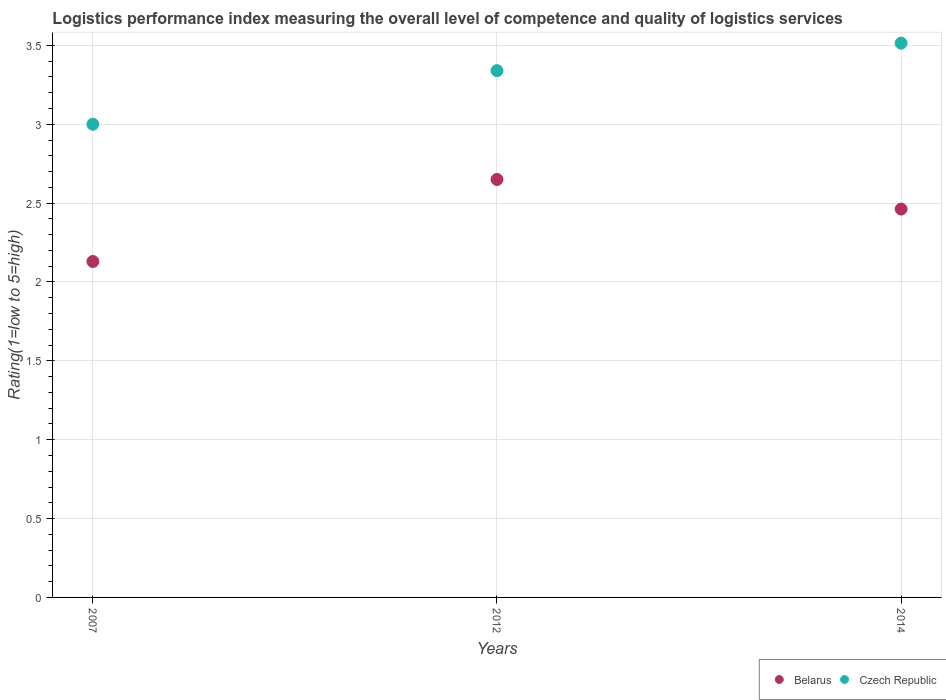What is the Logistic performance index in Belarus in 2007?
Your response must be concise. 2.13. Across all years, what is the maximum Logistic performance index in Czech Republic?
Ensure brevity in your answer.  3.51. In which year was the Logistic performance index in Belarus maximum?
Make the answer very short. 2012. In which year was the Logistic performance index in Czech Republic minimum?
Your answer should be very brief. 2007. What is the total Logistic performance index in Czech Republic in the graph?
Provide a succinct answer. 9.85. What is the difference between the Logistic performance index in Belarus in 2012 and that in 2014?
Your answer should be very brief. 0.19. What is the difference between the Logistic performance index in Czech Republic in 2014 and the Logistic performance index in Belarus in 2012?
Your answer should be compact. 0.86. What is the average Logistic performance index in Czech Republic per year?
Provide a short and direct response. 3.28. In the year 2007, what is the difference between the Logistic performance index in Czech Republic and Logistic performance index in Belarus?
Give a very brief answer. 0.87. In how many years, is the Logistic performance index in Belarus greater than 1?
Keep it short and to the point. 3. What is the ratio of the Logistic performance index in Belarus in 2012 to that in 2014?
Offer a terse response. 1.08. Is the Logistic performance index in Belarus in 2007 less than that in 2014?
Your response must be concise. Yes. Is the difference between the Logistic performance index in Czech Republic in 2007 and 2014 greater than the difference between the Logistic performance index in Belarus in 2007 and 2014?
Your response must be concise. No. What is the difference between the highest and the second highest Logistic performance index in Czech Republic?
Keep it short and to the point. 0.17. What is the difference between the highest and the lowest Logistic performance index in Belarus?
Your response must be concise. 0.52. In how many years, is the Logistic performance index in Czech Republic greater than the average Logistic performance index in Czech Republic taken over all years?
Make the answer very short. 2. Is the sum of the Logistic performance index in Czech Republic in 2012 and 2014 greater than the maximum Logistic performance index in Belarus across all years?
Ensure brevity in your answer.  Yes. Does the Logistic performance index in Belarus monotonically increase over the years?
Your answer should be compact. No. Is the Logistic performance index in Czech Republic strictly less than the Logistic performance index in Belarus over the years?
Offer a terse response. No. What is the difference between two consecutive major ticks on the Y-axis?
Make the answer very short. 0.5. Does the graph contain grids?
Give a very brief answer. Yes. Where does the legend appear in the graph?
Provide a succinct answer. Bottom right. How many legend labels are there?
Your response must be concise. 2. What is the title of the graph?
Your answer should be compact. Logistics performance index measuring the overall level of competence and quality of logistics services. Does "Sri Lanka" appear as one of the legend labels in the graph?
Offer a terse response. No. What is the label or title of the X-axis?
Provide a succinct answer. Years. What is the label or title of the Y-axis?
Keep it short and to the point. Rating(1=low to 5=high). What is the Rating(1=low to 5=high) of Belarus in 2007?
Your answer should be compact. 2.13. What is the Rating(1=low to 5=high) in Belarus in 2012?
Give a very brief answer. 2.65. What is the Rating(1=low to 5=high) of Czech Republic in 2012?
Keep it short and to the point. 3.34. What is the Rating(1=low to 5=high) of Belarus in 2014?
Keep it short and to the point. 2.46. What is the Rating(1=low to 5=high) in Czech Republic in 2014?
Ensure brevity in your answer.  3.51. Across all years, what is the maximum Rating(1=low to 5=high) in Belarus?
Provide a succinct answer. 2.65. Across all years, what is the maximum Rating(1=low to 5=high) in Czech Republic?
Offer a very short reply. 3.51. Across all years, what is the minimum Rating(1=low to 5=high) of Belarus?
Your answer should be very brief. 2.13. Across all years, what is the minimum Rating(1=low to 5=high) of Czech Republic?
Offer a very short reply. 3. What is the total Rating(1=low to 5=high) of Belarus in the graph?
Ensure brevity in your answer.  7.24. What is the total Rating(1=low to 5=high) in Czech Republic in the graph?
Make the answer very short. 9.85. What is the difference between the Rating(1=low to 5=high) of Belarus in 2007 and that in 2012?
Provide a succinct answer. -0.52. What is the difference between the Rating(1=low to 5=high) in Czech Republic in 2007 and that in 2012?
Provide a short and direct response. -0.34. What is the difference between the Rating(1=low to 5=high) in Belarus in 2007 and that in 2014?
Offer a terse response. -0.33. What is the difference between the Rating(1=low to 5=high) in Czech Republic in 2007 and that in 2014?
Give a very brief answer. -0.51. What is the difference between the Rating(1=low to 5=high) in Belarus in 2012 and that in 2014?
Offer a very short reply. 0.19. What is the difference between the Rating(1=low to 5=high) of Czech Republic in 2012 and that in 2014?
Your answer should be compact. -0.17. What is the difference between the Rating(1=low to 5=high) of Belarus in 2007 and the Rating(1=low to 5=high) of Czech Republic in 2012?
Ensure brevity in your answer.  -1.21. What is the difference between the Rating(1=low to 5=high) of Belarus in 2007 and the Rating(1=low to 5=high) of Czech Republic in 2014?
Your answer should be very brief. -1.38. What is the difference between the Rating(1=low to 5=high) in Belarus in 2012 and the Rating(1=low to 5=high) in Czech Republic in 2014?
Your answer should be compact. -0.86. What is the average Rating(1=low to 5=high) of Belarus per year?
Ensure brevity in your answer.  2.41. What is the average Rating(1=low to 5=high) of Czech Republic per year?
Your answer should be compact. 3.28. In the year 2007, what is the difference between the Rating(1=low to 5=high) in Belarus and Rating(1=low to 5=high) in Czech Republic?
Offer a very short reply. -0.87. In the year 2012, what is the difference between the Rating(1=low to 5=high) in Belarus and Rating(1=low to 5=high) in Czech Republic?
Your answer should be very brief. -0.69. In the year 2014, what is the difference between the Rating(1=low to 5=high) in Belarus and Rating(1=low to 5=high) in Czech Republic?
Offer a terse response. -1.05. What is the ratio of the Rating(1=low to 5=high) in Belarus in 2007 to that in 2012?
Offer a very short reply. 0.8. What is the ratio of the Rating(1=low to 5=high) in Czech Republic in 2007 to that in 2012?
Your response must be concise. 0.9. What is the ratio of the Rating(1=low to 5=high) in Belarus in 2007 to that in 2014?
Offer a terse response. 0.86. What is the ratio of the Rating(1=low to 5=high) of Czech Republic in 2007 to that in 2014?
Provide a succinct answer. 0.85. What is the ratio of the Rating(1=low to 5=high) in Belarus in 2012 to that in 2014?
Your answer should be very brief. 1.08. What is the ratio of the Rating(1=low to 5=high) of Czech Republic in 2012 to that in 2014?
Offer a terse response. 0.95. What is the difference between the highest and the second highest Rating(1=low to 5=high) in Belarus?
Give a very brief answer. 0.19. What is the difference between the highest and the second highest Rating(1=low to 5=high) of Czech Republic?
Offer a terse response. 0.17. What is the difference between the highest and the lowest Rating(1=low to 5=high) of Belarus?
Your response must be concise. 0.52. What is the difference between the highest and the lowest Rating(1=low to 5=high) of Czech Republic?
Ensure brevity in your answer.  0.51. 